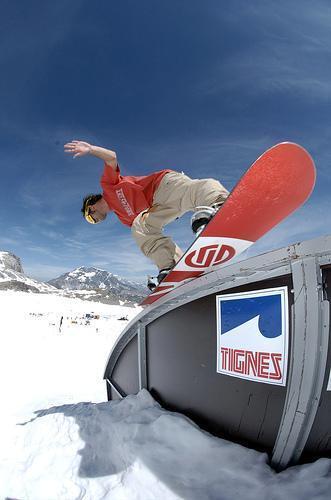How many of the man's hands are visible?
Give a very brief answer. 1. 